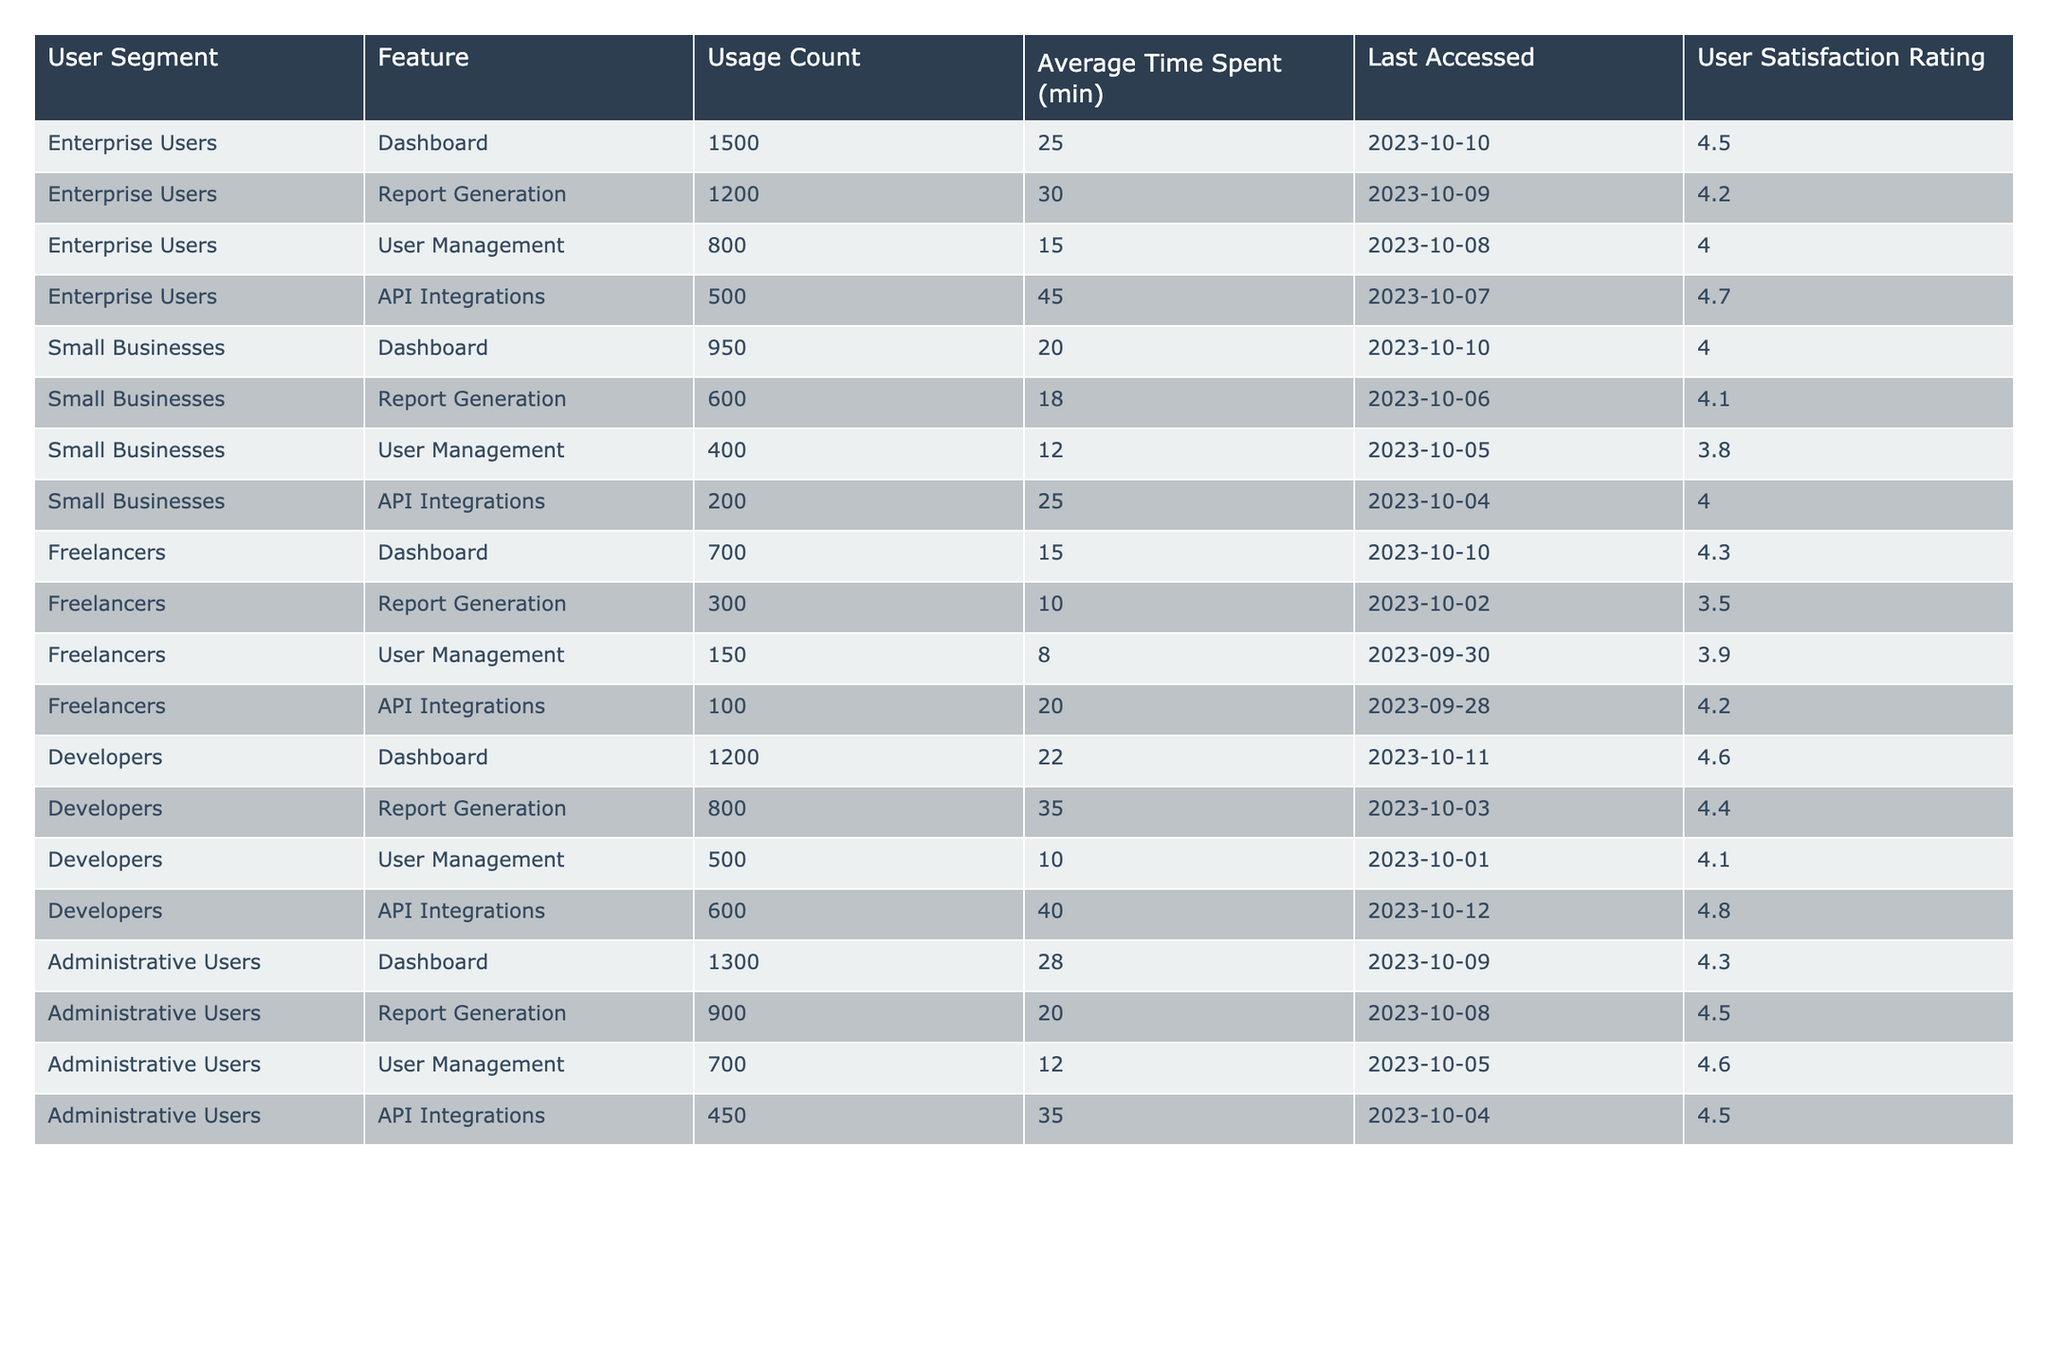What is the user satisfaction rating for API Integrations among Enterprise Users? The table indicates that the user satisfaction rating for API Integrations in the Enterprise Users segment is 4.7.
Answer: 4.7 Which feature has the highest usage count for Small Businesses? By examining the table, the feature with the highest usage count for Small Businesses is the Dashboard, with a count of 950.
Answer: Dashboard What is the average time spent on Report Generation by Developers? From the table, the average time spent on Report Generation by Developers is 35 minutes.
Answer: 35 minutes Which user segment has the lowest user satisfaction rating for User Management? The table shows that Freelancers have the lowest user satisfaction rating for User Management at 3.9.
Answer: Freelancers What is the total usage count for all features combined for Administrative Users? Adding the usage counts for Administrative Users: 1300 (Dashboard) + 900 (Report Generation) + 700 (User Management) + 450 (API Integrations) gives a total of 3350.
Answer: 3350 Is the average time spent on the Dashboard higher for Developers than for Freelancers? The Dashboard for Developers shows an average time of 22 minutes, while Freelancers spend 15 minutes on the same feature. Therefore, Developers spend more time on it.
Answer: Yes What is the difference in usage count for Report Generation between Enterprise Users and Small Businesses? The usage count for Report Generation is 1200 for Enterprise Users and 600 for Small Businesses. The difference is 1200 - 600 = 600.
Answer: 600 Which feature has the lowest user satisfaction rating in the Small Businesses segment? Examining the table, User Management has the lowest user satisfaction rating among Small Businesses at 3.8.
Answer: User Management What is the average user satisfaction rating across all features for Administrative Users? Adding the ratings: 4.3 (Dashboard) + 4.5 (Report Generation) + 4.6 (User Management) + 4.5 (API Integrations) = 18.9; dividing by 4 gives an average of 4.725, which rounds to 4.7.
Answer: 4.7 What percentage of total usage for Enterprise Users comes from the Dashboard? The total usage for Enterprise Users is 1500 + 1200 + 800 + 500 = 4000; the Dashboard count is 1500. Thus, (1500/4000) * 100 = 37.5%.
Answer: 37.5% 